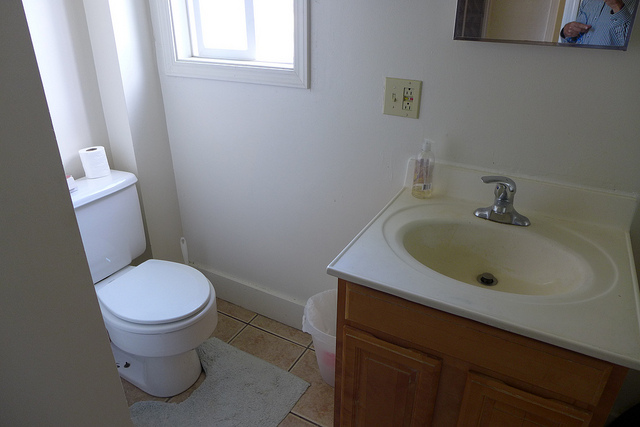How many windows? The image shows exactly one window positioned above the toilet, allowing natural light to enter the bathroom. 